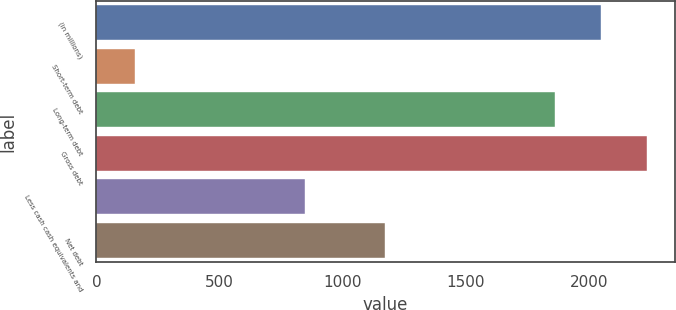Convert chart. <chart><loc_0><loc_0><loc_500><loc_500><bar_chart><fcel>(in millions)<fcel>Short-term debt<fcel>Long-term debt<fcel>Gross debt<fcel>Less cash cash equivalents and<fcel>Net debt<nl><fcel>2050.4<fcel>156<fcel>1864<fcel>2236.8<fcel>848<fcel>1172<nl></chart> 